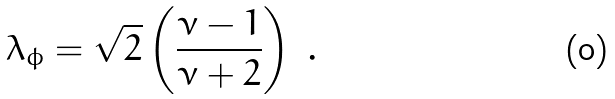Convert formula to latex. <formula><loc_0><loc_0><loc_500><loc_500>\lambda _ { \phi } = \sqrt { 2 } \left ( \frac { \nu - 1 } { \nu + 2 } \right ) \ .</formula> 